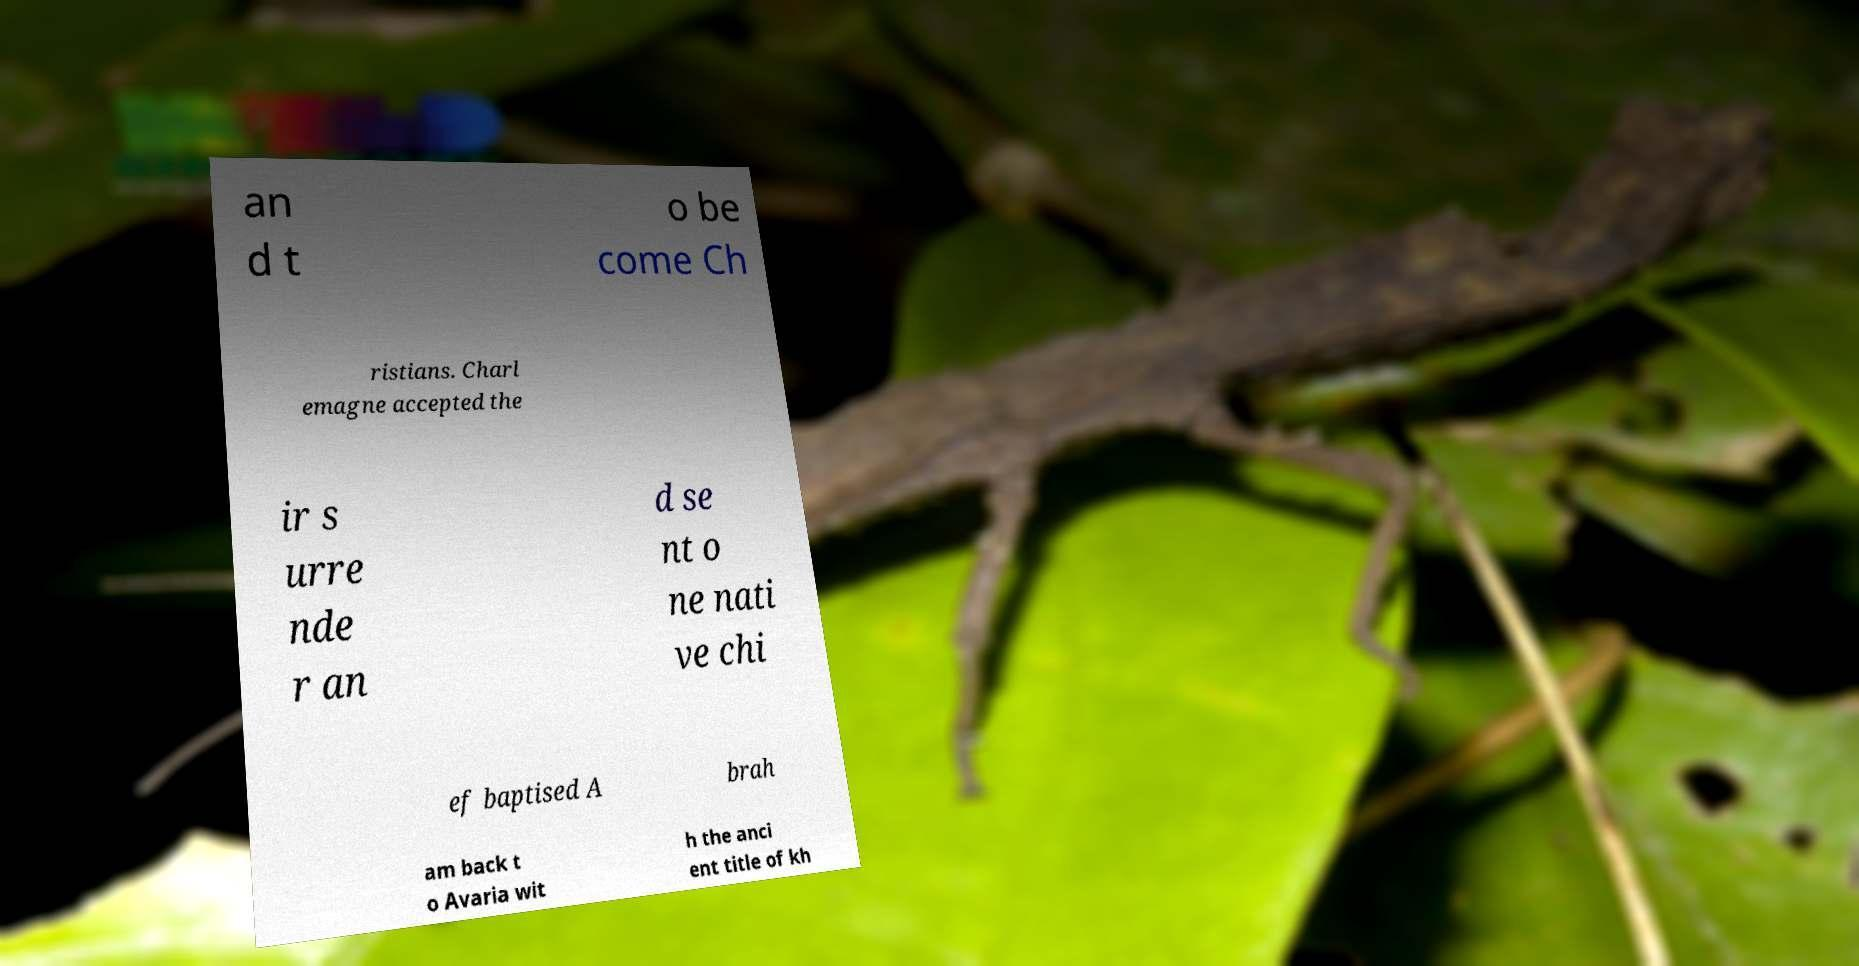Please read and relay the text visible in this image. What does it say? an d t o be come Ch ristians. Charl emagne accepted the ir s urre nde r an d se nt o ne nati ve chi ef baptised A brah am back t o Avaria wit h the anci ent title of kh 